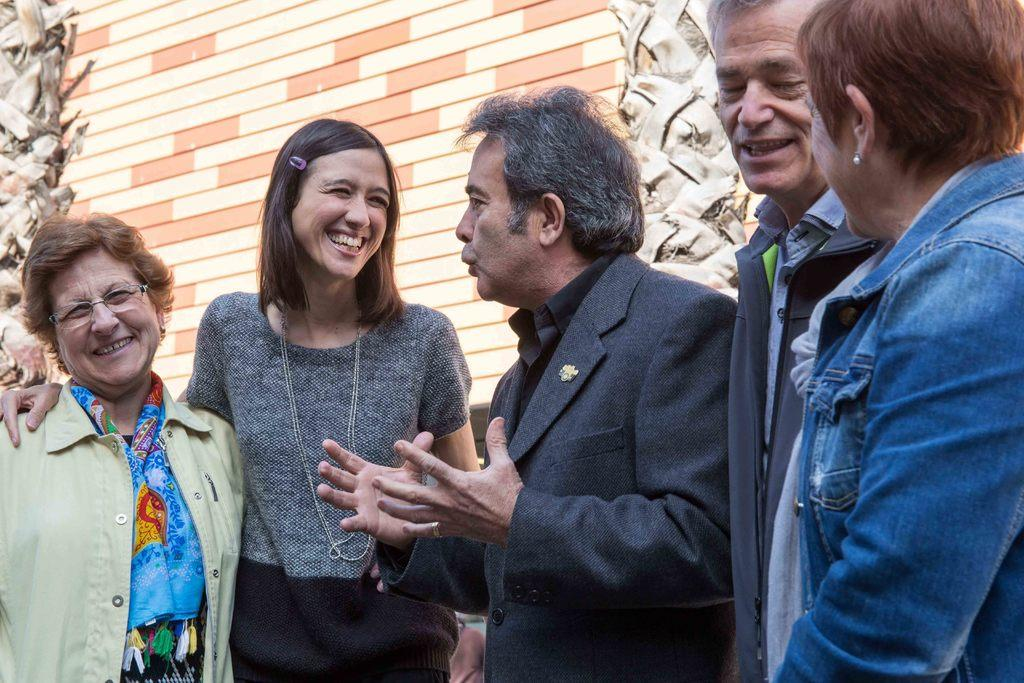What are the people in the image doing? The people in the image are standing in the center and smiling. What can be seen in the background of the image? There is a wall and poles in the background of the image. What type of chin can be seen on the person in the image? There is no chin visible in the image, as it only shows people standing and smiling. 